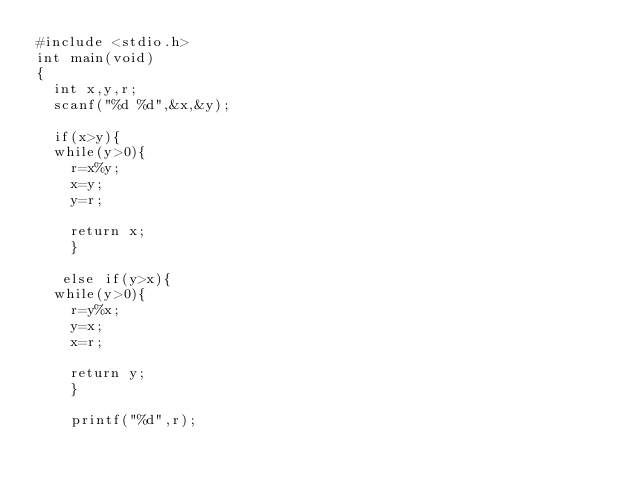Convert code to text. <code><loc_0><loc_0><loc_500><loc_500><_C_>#include <stdio.h>
int main(void)
{
  int x,y,r;
  scanf("%d %d",&x,&y);
  
  if(x>y){
  while(y>0){
    r=x%y;
    x=y;
    y=r;
   
    return x;
    }

   else if(y>x){
  while(y>0){
    r=y%x;
    y=x;
    x=r;
   
    return y;
    }

    printf("%d",r);</code> 